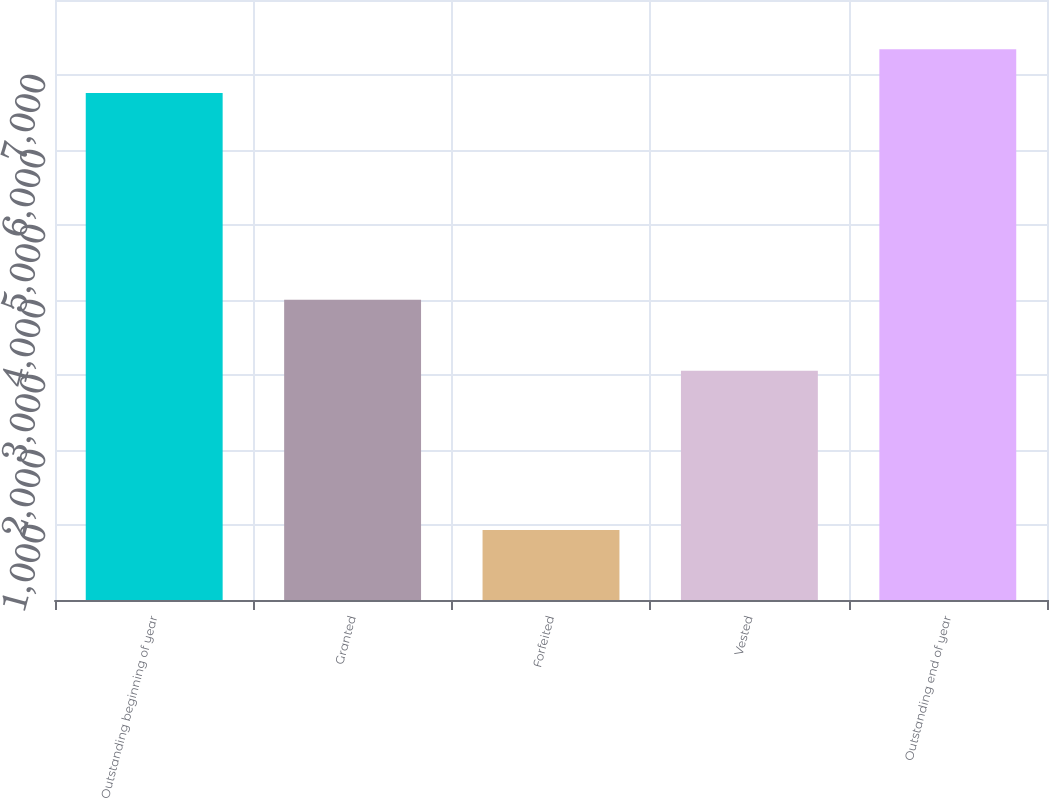<chart> <loc_0><loc_0><loc_500><loc_500><bar_chart><fcel>Outstanding beginning of year<fcel>Granted<fcel>Forfeited<fcel>Vested<fcel>Outstanding end of year<nl><fcel>6760<fcel>4002<fcel>935<fcel>3056<fcel>7343.6<nl></chart> 